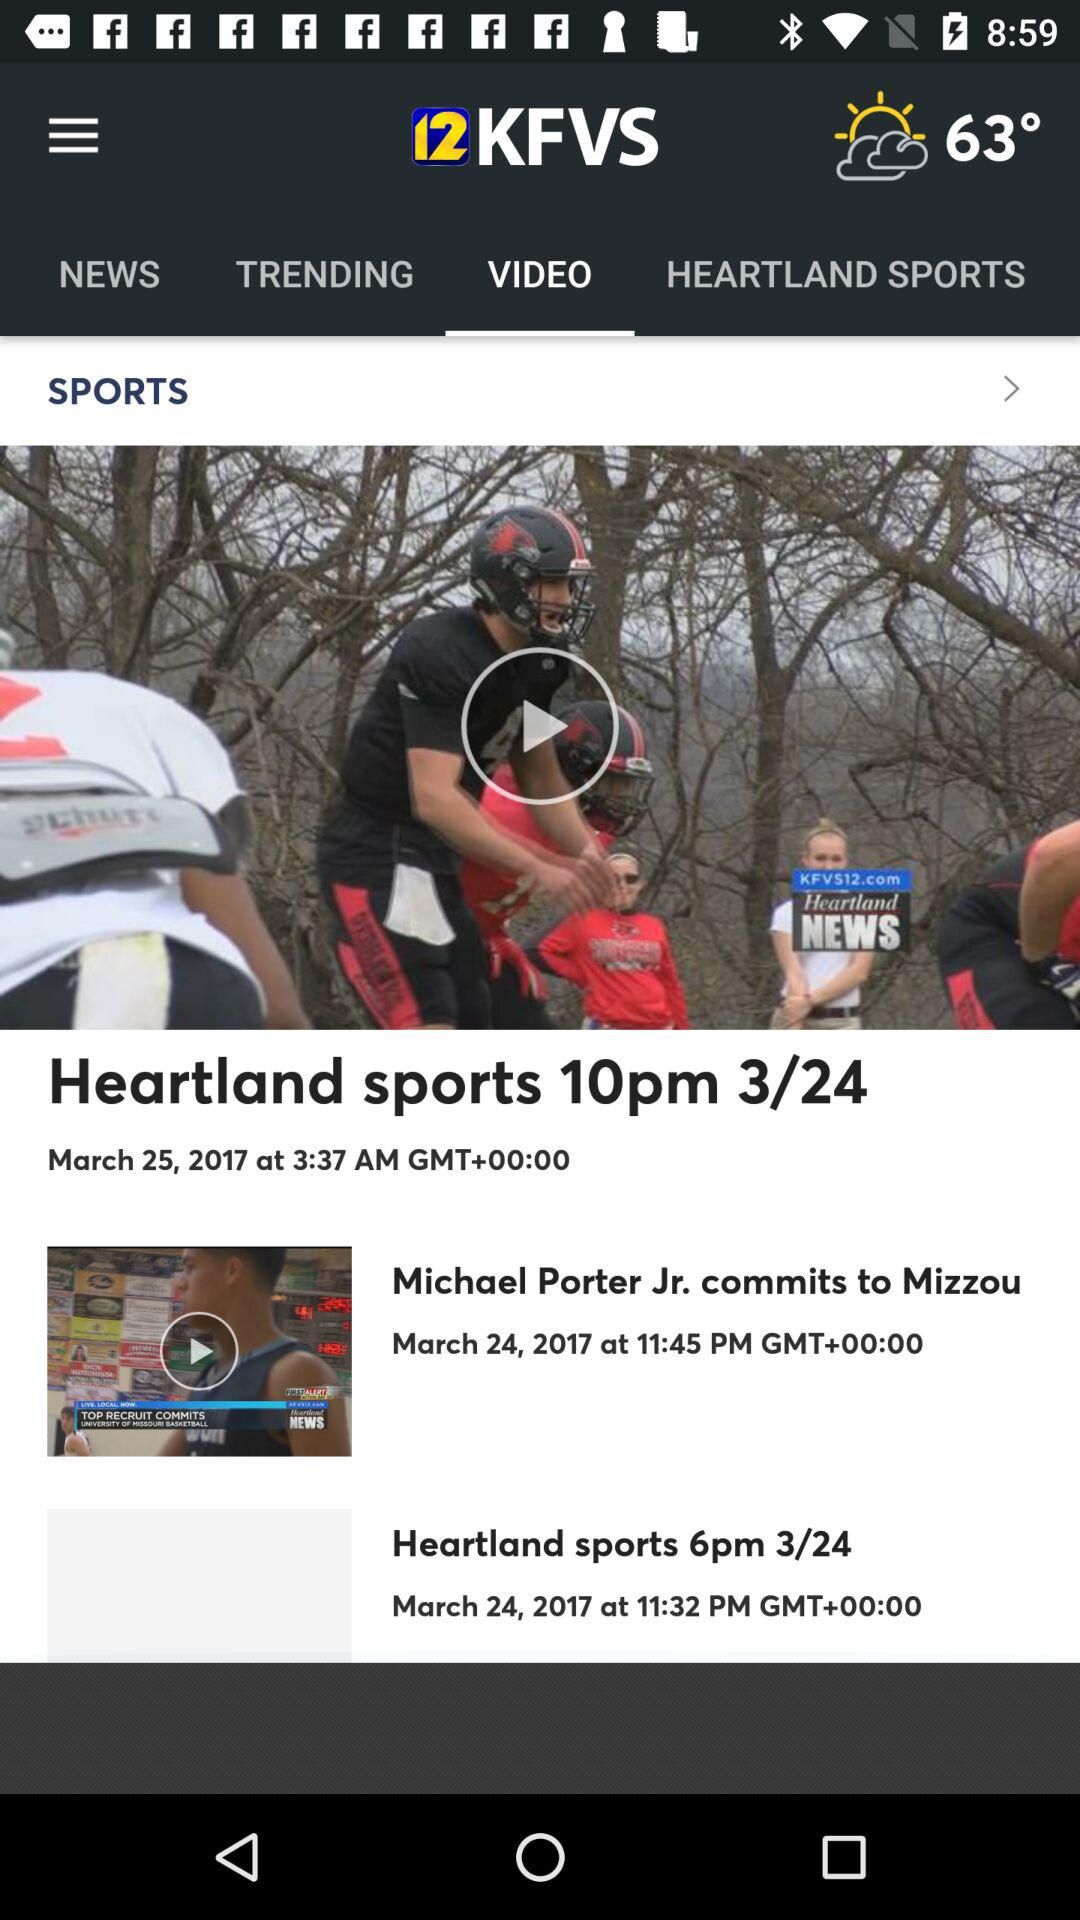What is the published time of the news for "Heartland sports 6pm 3/24"? The published time of the news is 11:32 PM. 